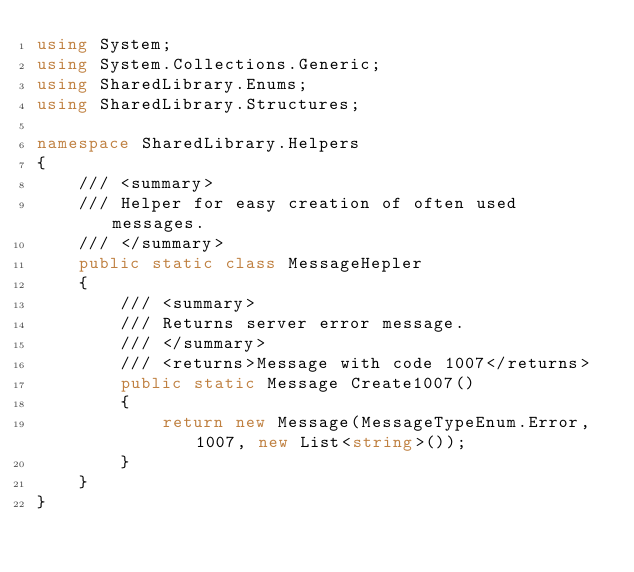<code> <loc_0><loc_0><loc_500><loc_500><_C#_>using System;
using System.Collections.Generic;
using SharedLibrary.Enums;
using SharedLibrary.Structures;

namespace SharedLibrary.Helpers
{
    /// <summary>
    /// Helper for easy creation of often used messages.
    /// </summary>
    public static class MessageHepler
    {
        /// <summary>
        /// Returns server error message.
        /// </summary>
        /// <returns>Message with code 1007</returns>
        public static Message Create1007()
        {
            return new Message(MessageTypeEnum.Error, 1007, new List<string>());
        }
    }
}</code> 